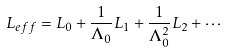<formula> <loc_0><loc_0><loc_500><loc_500>L _ { e f f } = L _ { 0 } + \frac { 1 } { \Lambda _ { 0 } } L _ { 1 } + \frac { 1 } { \Lambda _ { 0 } ^ { 2 } } L _ { 2 } + \cdots</formula> 